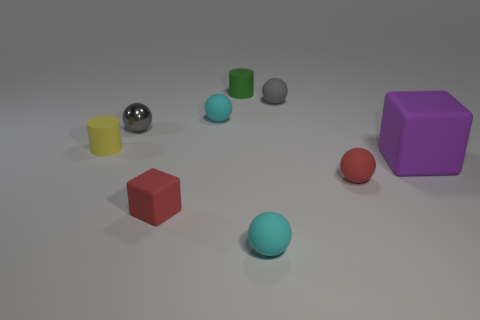Subtract all red balls. How many balls are left? 4 Subtract all tiny red matte spheres. How many spheres are left? 4 Subtract 2 spheres. How many spheres are left? 3 Subtract all gray blocks. Subtract all blue balls. How many blocks are left? 2 Add 1 tiny metal objects. How many objects exist? 10 Subtract all balls. How many objects are left? 4 Add 9 large blue things. How many large blue things exist? 9 Subtract 0 red cylinders. How many objects are left? 9 Subtract all big purple metal cubes. Subtract all cyan matte spheres. How many objects are left? 7 Add 4 big purple things. How many big purple things are left? 5 